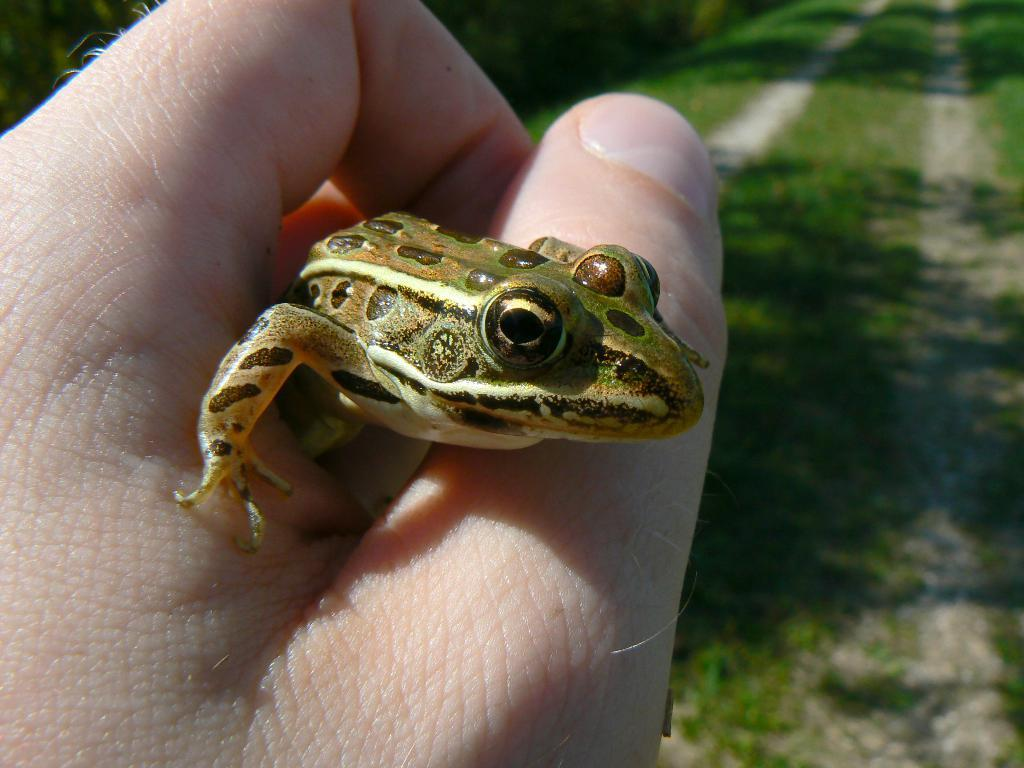Who or what is present in the image? There is a person in the image. What is the person holding in their hand? The person is holding a frog in their hand. What type of surface is visible on the ground in the image? There is grass on the ground in the image. What type of pest can be seen in the image? There is no pest visible in the image; it features a person holding a frog. What type of school is depicted in the image? There is no school present in the image. 